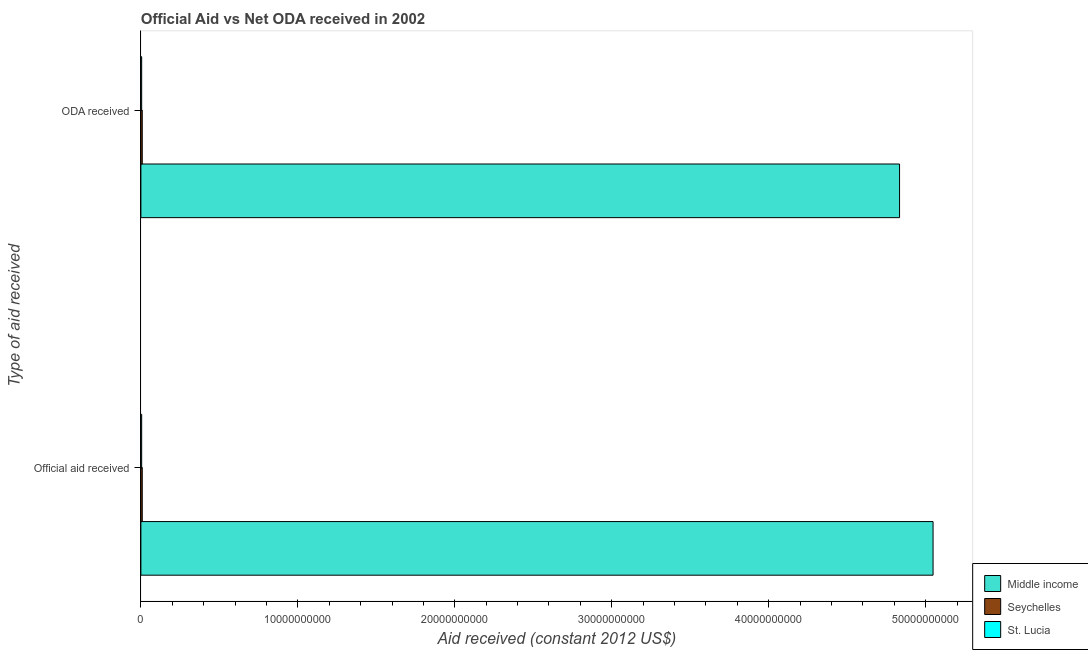How many different coloured bars are there?
Keep it short and to the point. 3. How many groups of bars are there?
Keep it short and to the point. 2. Are the number of bars per tick equal to the number of legend labels?
Provide a succinct answer. Yes. Are the number of bars on each tick of the Y-axis equal?
Your answer should be compact. Yes. How many bars are there on the 2nd tick from the top?
Your answer should be very brief. 3. How many bars are there on the 1st tick from the bottom?
Ensure brevity in your answer.  3. What is the label of the 2nd group of bars from the top?
Provide a succinct answer. Official aid received. What is the official aid received in Middle income?
Your answer should be very brief. 5.05e+1. Across all countries, what is the maximum official aid received?
Ensure brevity in your answer.  5.05e+1. Across all countries, what is the minimum official aid received?
Your answer should be very brief. 5.03e+07. In which country was the official aid received maximum?
Your answer should be compact. Middle income. In which country was the official aid received minimum?
Your answer should be very brief. St. Lucia. What is the total oda received in the graph?
Offer a terse response. 4.85e+1. What is the difference between the oda received in St. Lucia and that in Seychelles?
Offer a very short reply. -3.79e+07. What is the difference between the oda received in Middle income and the official aid received in St. Lucia?
Ensure brevity in your answer.  4.83e+1. What is the average oda received per country?
Provide a short and direct response. 1.62e+1. What is the difference between the official aid received and oda received in St. Lucia?
Your answer should be very brief. 0. What is the ratio of the official aid received in Middle income to that in St. Lucia?
Ensure brevity in your answer.  1003.82. What does the 2nd bar from the top in ODA received represents?
Give a very brief answer. Seychelles. What does the 2nd bar from the bottom in ODA received represents?
Provide a short and direct response. Seychelles. How many bars are there?
Keep it short and to the point. 6. What is the difference between two consecutive major ticks on the X-axis?
Make the answer very short. 1.00e+1. Does the graph contain grids?
Keep it short and to the point. No. How many legend labels are there?
Provide a short and direct response. 3. How are the legend labels stacked?
Ensure brevity in your answer.  Vertical. What is the title of the graph?
Ensure brevity in your answer.  Official Aid vs Net ODA received in 2002 . What is the label or title of the X-axis?
Offer a very short reply. Aid received (constant 2012 US$). What is the label or title of the Y-axis?
Offer a very short reply. Type of aid received. What is the Aid received (constant 2012 US$) of Middle income in Official aid received?
Your answer should be compact. 5.05e+1. What is the Aid received (constant 2012 US$) of Seychelles in Official aid received?
Provide a short and direct response. 8.82e+07. What is the Aid received (constant 2012 US$) of St. Lucia in Official aid received?
Offer a very short reply. 5.03e+07. What is the Aid received (constant 2012 US$) of Middle income in ODA received?
Your answer should be very brief. 4.83e+1. What is the Aid received (constant 2012 US$) in Seychelles in ODA received?
Your response must be concise. 8.82e+07. What is the Aid received (constant 2012 US$) of St. Lucia in ODA received?
Ensure brevity in your answer.  5.03e+07. Across all Type of aid received, what is the maximum Aid received (constant 2012 US$) in Middle income?
Ensure brevity in your answer.  5.05e+1. Across all Type of aid received, what is the maximum Aid received (constant 2012 US$) of Seychelles?
Keep it short and to the point. 8.82e+07. Across all Type of aid received, what is the maximum Aid received (constant 2012 US$) of St. Lucia?
Your answer should be very brief. 5.03e+07. Across all Type of aid received, what is the minimum Aid received (constant 2012 US$) in Middle income?
Offer a terse response. 4.83e+1. Across all Type of aid received, what is the minimum Aid received (constant 2012 US$) in Seychelles?
Make the answer very short. 8.82e+07. Across all Type of aid received, what is the minimum Aid received (constant 2012 US$) in St. Lucia?
Keep it short and to the point. 5.03e+07. What is the total Aid received (constant 2012 US$) of Middle income in the graph?
Make the answer very short. 9.88e+1. What is the total Aid received (constant 2012 US$) of Seychelles in the graph?
Provide a succinct answer. 1.76e+08. What is the total Aid received (constant 2012 US$) in St. Lucia in the graph?
Give a very brief answer. 1.01e+08. What is the difference between the Aid received (constant 2012 US$) of Middle income in Official aid received and that in ODA received?
Your answer should be very brief. 2.13e+09. What is the difference between the Aid received (constant 2012 US$) in Seychelles in Official aid received and that in ODA received?
Your answer should be compact. 0. What is the difference between the Aid received (constant 2012 US$) of St. Lucia in Official aid received and that in ODA received?
Provide a succinct answer. 0. What is the difference between the Aid received (constant 2012 US$) of Middle income in Official aid received and the Aid received (constant 2012 US$) of Seychelles in ODA received?
Offer a very short reply. 5.04e+1. What is the difference between the Aid received (constant 2012 US$) of Middle income in Official aid received and the Aid received (constant 2012 US$) of St. Lucia in ODA received?
Your answer should be very brief. 5.04e+1. What is the difference between the Aid received (constant 2012 US$) in Seychelles in Official aid received and the Aid received (constant 2012 US$) in St. Lucia in ODA received?
Your answer should be compact. 3.79e+07. What is the average Aid received (constant 2012 US$) of Middle income per Type of aid received?
Your answer should be very brief. 4.94e+1. What is the average Aid received (constant 2012 US$) in Seychelles per Type of aid received?
Your answer should be compact. 8.82e+07. What is the average Aid received (constant 2012 US$) in St. Lucia per Type of aid received?
Ensure brevity in your answer.  5.03e+07. What is the difference between the Aid received (constant 2012 US$) in Middle income and Aid received (constant 2012 US$) in Seychelles in Official aid received?
Provide a short and direct response. 5.04e+1. What is the difference between the Aid received (constant 2012 US$) of Middle income and Aid received (constant 2012 US$) of St. Lucia in Official aid received?
Make the answer very short. 5.04e+1. What is the difference between the Aid received (constant 2012 US$) of Seychelles and Aid received (constant 2012 US$) of St. Lucia in Official aid received?
Offer a terse response. 3.79e+07. What is the difference between the Aid received (constant 2012 US$) of Middle income and Aid received (constant 2012 US$) of Seychelles in ODA received?
Your answer should be very brief. 4.83e+1. What is the difference between the Aid received (constant 2012 US$) of Middle income and Aid received (constant 2012 US$) of St. Lucia in ODA received?
Your response must be concise. 4.83e+1. What is the difference between the Aid received (constant 2012 US$) in Seychelles and Aid received (constant 2012 US$) in St. Lucia in ODA received?
Your answer should be very brief. 3.79e+07. What is the ratio of the Aid received (constant 2012 US$) in Middle income in Official aid received to that in ODA received?
Make the answer very short. 1.04. What is the ratio of the Aid received (constant 2012 US$) of Seychelles in Official aid received to that in ODA received?
Offer a very short reply. 1. What is the difference between the highest and the second highest Aid received (constant 2012 US$) in Middle income?
Provide a short and direct response. 2.13e+09. What is the difference between the highest and the lowest Aid received (constant 2012 US$) in Middle income?
Make the answer very short. 2.13e+09. 